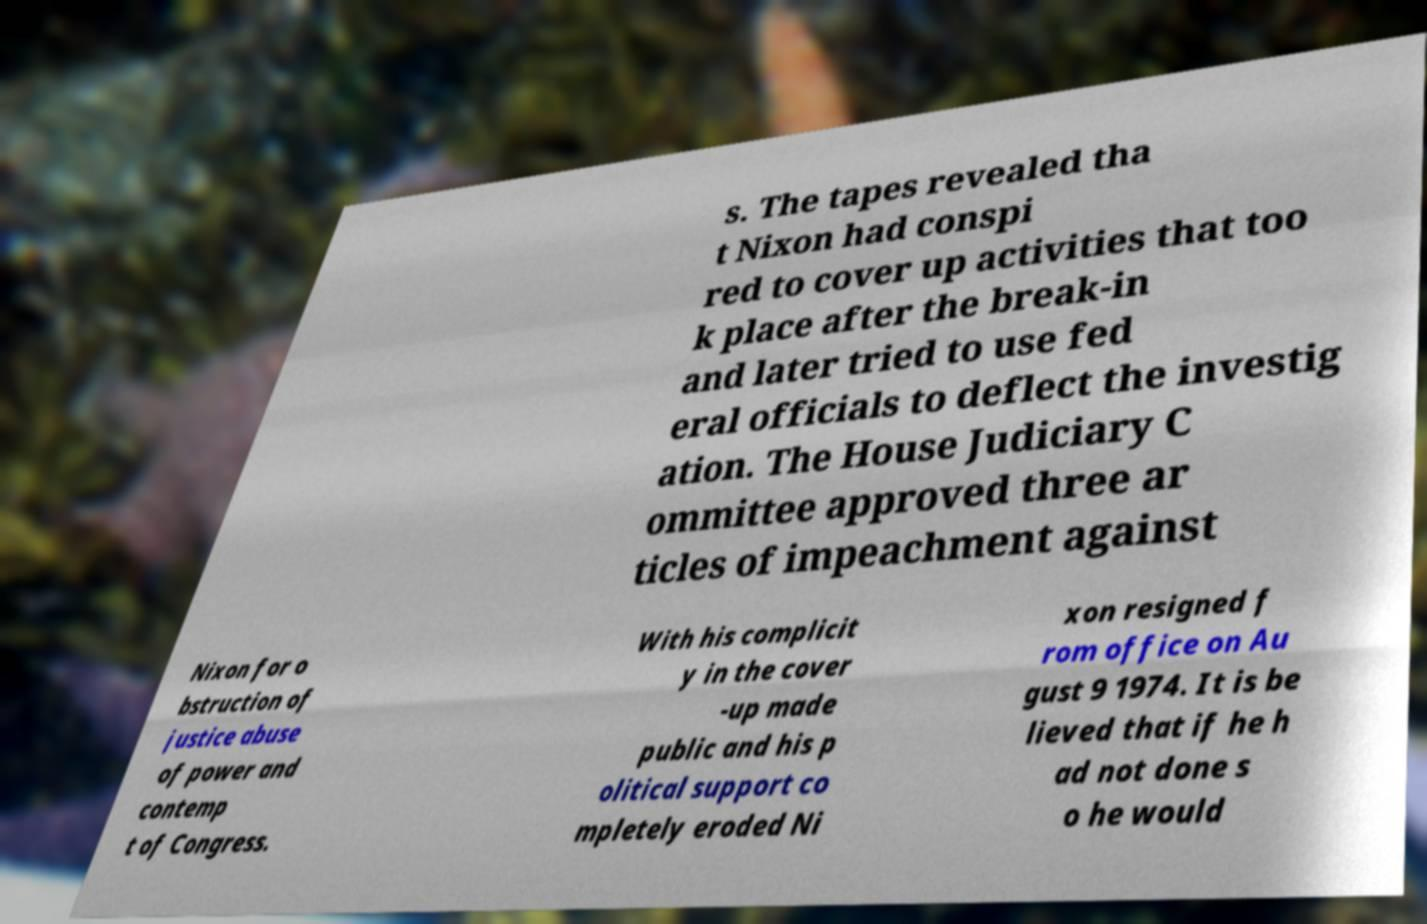Could you assist in decoding the text presented in this image and type it out clearly? s. The tapes revealed tha t Nixon had conspi red to cover up activities that too k place after the break-in and later tried to use fed eral officials to deflect the investig ation. The House Judiciary C ommittee approved three ar ticles of impeachment against Nixon for o bstruction of justice abuse of power and contemp t of Congress. With his complicit y in the cover -up made public and his p olitical support co mpletely eroded Ni xon resigned f rom office on Au gust 9 1974. It is be lieved that if he h ad not done s o he would 